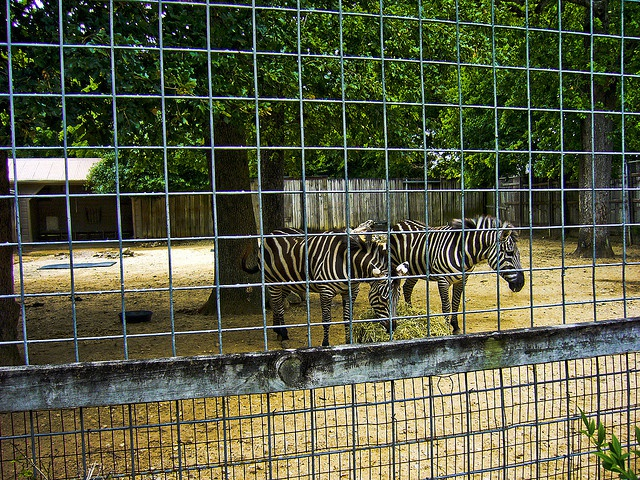Describe the objects in this image and their specific colors. I can see zebra in black, olive, and gray tones and zebra in black, olive, white, and gray tones in this image. 